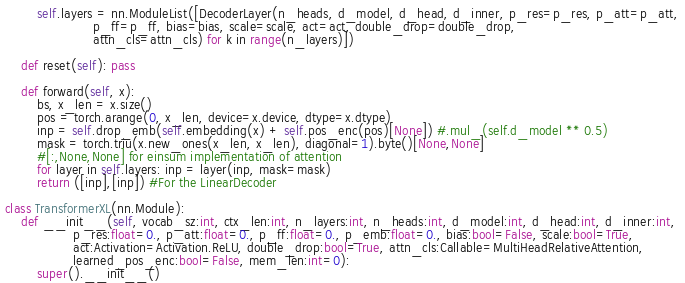Convert code to text. <code><loc_0><loc_0><loc_500><loc_500><_Python_>        self.layers = nn.ModuleList([DecoderLayer(n_heads, d_model, d_head, d_inner, p_res=p_res, p_att=p_att,
                      p_ff=p_ff, bias=bias, scale=scale, act=act, double_drop=double_drop, 
                      attn_cls=attn_cls) for k in range(n_layers)])
    
    def reset(self): pass
    
    def forward(self, x):
        bs, x_len = x.size()
        pos = torch.arange(0, x_len, device=x.device, dtype=x.dtype)
        inp = self.drop_emb(self.embedding(x) + self.pos_enc(pos)[None]) #.mul_(self.d_model ** 0.5)
        mask = torch.triu(x.new_ones(x_len, x_len), diagonal=1).byte()[None,None]
        #[:,None,None] for einsum implementation of attention
        for layer in self.layers: inp = layer(inp, mask=mask)
        return ([inp],[inp]) #For the LinearDecoder

class TransformerXL(nn.Module):
    def __init__(self, vocab_sz:int, ctx_len:int, n_layers:int, n_heads:int, d_model:int, d_head:int, d_inner:int, 
                 p_res:float=0., p_att:float=0., p_ff:float=0., p_emb:float=0., bias:bool=False, scale:bool=True,
                 act:Activation=Activation.ReLU, double_drop:bool=True, attn_cls:Callable=MultiHeadRelativeAttention,
                 learned_pos_enc:bool=False, mem_len:int=0):
        super().__init__()</code> 